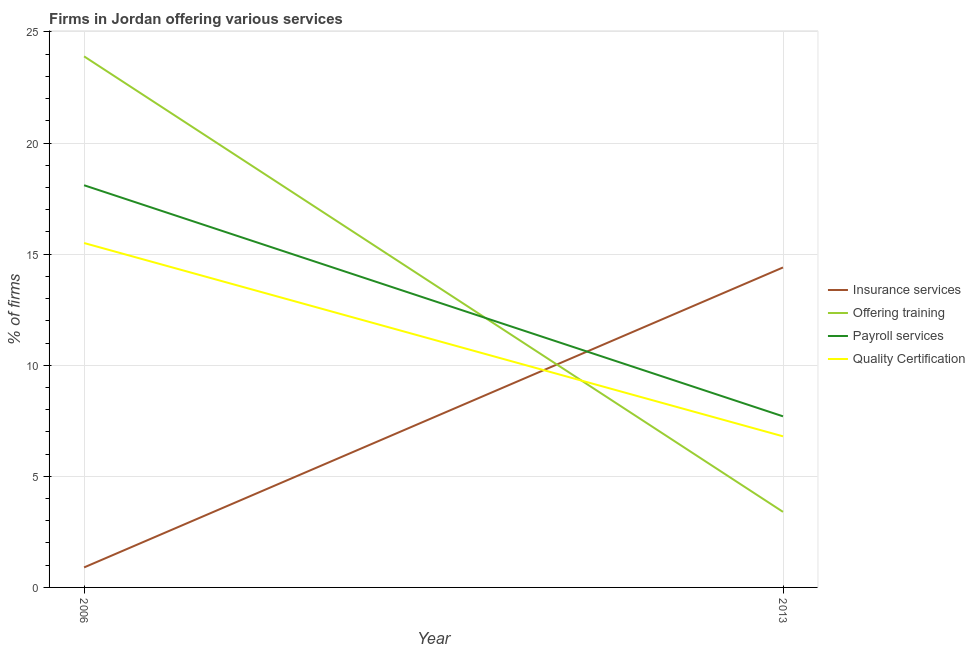How many different coloured lines are there?
Keep it short and to the point. 4. Does the line corresponding to percentage of firms offering quality certification intersect with the line corresponding to percentage of firms offering insurance services?
Your answer should be very brief. Yes. Is the number of lines equal to the number of legend labels?
Provide a succinct answer. Yes. What is the percentage of firms offering training in 2006?
Ensure brevity in your answer.  23.9. Across all years, what is the maximum percentage of firms offering payroll services?
Your response must be concise. 18.1. Across all years, what is the minimum percentage of firms offering training?
Provide a short and direct response. 3.4. What is the total percentage of firms offering quality certification in the graph?
Give a very brief answer. 22.3. What is the difference between the percentage of firms offering payroll services in 2006 and that in 2013?
Offer a very short reply. 10.4. What is the difference between the percentage of firms offering training in 2006 and the percentage of firms offering payroll services in 2013?
Offer a terse response. 16.2. What is the average percentage of firms offering payroll services per year?
Give a very brief answer. 12.9. In the year 2013, what is the difference between the percentage of firms offering training and percentage of firms offering payroll services?
Keep it short and to the point. -4.3. In how many years, is the percentage of firms offering training greater than 13 %?
Your answer should be compact. 1. What is the ratio of the percentage of firms offering training in 2006 to that in 2013?
Give a very brief answer. 7.03. In how many years, is the percentage of firms offering training greater than the average percentage of firms offering training taken over all years?
Offer a very short reply. 1. Is it the case that in every year, the sum of the percentage of firms offering payroll services and percentage of firms offering insurance services is greater than the sum of percentage of firms offering quality certification and percentage of firms offering training?
Your answer should be very brief. No. Is it the case that in every year, the sum of the percentage of firms offering insurance services and percentage of firms offering training is greater than the percentage of firms offering payroll services?
Your answer should be very brief. Yes. Is the percentage of firms offering payroll services strictly less than the percentage of firms offering insurance services over the years?
Make the answer very short. No. How many years are there in the graph?
Provide a short and direct response. 2. Does the graph contain any zero values?
Offer a terse response. No. Does the graph contain grids?
Offer a terse response. Yes. Where does the legend appear in the graph?
Ensure brevity in your answer.  Center right. How are the legend labels stacked?
Provide a succinct answer. Vertical. What is the title of the graph?
Offer a terse response. Firms in Jordan offering various services . Does "HFC gas" appear as one of the legend labels in the graph?
Ensure brevity in your answer.  No. What is the label or title of the X-axis?
Give a very brief answer. Year. What is the label or title of the Y-axis?
Make the answer very short. % of firms. What is the % of firms of Offering training in 2006?
Keep it short and to the point. 23.9. What is the % of firms in Payroll services in 2006?
Provide a short and direct response. 18.1. What is the % of firms of Offering training in 2013?
Give a very brief answer. 3.4. What is the % of firms in Payroll services in 2013?
Ensure brevity in your answer.  7.7. What is the % of firms in Quality Certification in 2013?
Provide a succinct answer. 6.8. Across all years, what is the maximum % of firms in Insurance services?
Give a very brief answer. 14.4. Across all years, what is the maximum % of firms of Offering training?
Your answer should be very brief. 23.9. Across all years, what is the maximum % of firms in Quality Certification?
Make the answer very short. 15.5. Across all years, what is the minimum % of firms in Insurance services?
Keep it short and to the point. 0.9. Across all years, what is the minimum % of firms in Payroll services?
Offer a very short reply. 7.7. Across all years, what is the minimum % of firms of Quality Certification?
Offer a terse response. 6.8. What is the total % of firms in Insurance services in the graph?
Give a very brief answer. 15.3. What is the total % of firms in Offering training in the graph?
Your response must be concise. 27.3. What is the total % of firms of Payroll services in the graph?
Keep it short and to the point. 25.8. What is the total % of firms in Quality Certification in the graph?
Offer a terse response. 22.3. What is the difference between the % of firms of Offering training in 2006 and that in 2013?
Your answer should be compact. 20.5. What is the difference between the % of firms of Payroll services in 2006 and that in 2013?
Offer a very short reply. 10.4. What is the difference between the % of firms in Quality Certification in 2006 and that in 2013?
Provide a short and direct response. 8.7. What is the difference between the % of firms in Insurance services in 2006 and the % of firms in Offering training in 2013?
Give a very brief answer. -2.5. What is the difference between the % of firms of Insurance services in 2006 and the % of firms of Payroll services in 2013?
Your answer should be very brief. -6.8. What is the difference between the % of firms of Offering training in 2006 and the % of firms of Payroll services in 2013?
Make the answer very short. 16.2. What is the difference between the % of firms in Payroll services in 2006 and the % of firms in Quality Certification in 2013?
Your answer should be compact. 11.3. What is the average % of firms of Insurance services per year?
Provide a succinct answer. 7.65. What is the average % of firms in Offering training per year?
Ensure brevity in your answer.  13.65. What is the average % of firms of Payroll services per year?
Offer a very short reply. 12.9. What is the average % of firms of Quality Certification per year?
Your answer should be very brief. 11.15. In the year 2006, what is the difference between the % of firms of Insurance services and % of firms of Payroll services?
Offer a terse response. -17.2. In the year 2006, what is the difference between the % of firms of Insurance services and % of firms of Quality Certification?
Your answer should be compact. -14.6. In the year 2006, what is the difference between the % of firms of Offering training and % of firms of Payroll services?
Your answer should be compact. 5.8. In the year 2006, what is the difference between the % of firms of Offering training and % of firms of Quality Certification?
Make the answer very short. 8.4. In the year 2006, what is the difference between the % of firms of Payroll services and % of firms of Quality Certification?
Offer a terse response. 2.6. In the year 2013, what is the difference between the % of firms of Insurance services and % of firms of Offering training?
Give a very brief answer. 11. In the year 2013, what is the difference between the % of firms in Insurance services and % of firms in Payroll services?
Your answer should be compact. 6.7. In the year 2013, what is the difference between the % of firms of Offering training and % of firms of Quality Certification?
Ensure brevity in your answer.  -3.4. What is the ratio of the % of firms of Insurance services in 2006 to that in 2013?
Your answer should be very brief. 0.06. What is the ratio of the % of firms of Offering training in 2006 to that in 2013?
Give a very brief answer. 7.03. What is the ratio of the % of firms in Payroll services in 2006 to that in 2013?
Provide a short and direct response. 2.35. What is the ratio of the % of firms in Quality Certification in 2006 to that in 2013?
Give a very brief answer. 2.28. What is the difference between the highest and the second highest % of firms of Insurance services?
Offer a terse response. 13.5. What is the difference between the highest and the second highest % of firms of Payroll services?
Offer a terse response. 10.4. What is the difference between the highest and the lowest % of firms in Payroll services?
Offer a very short reply. 10.4. 